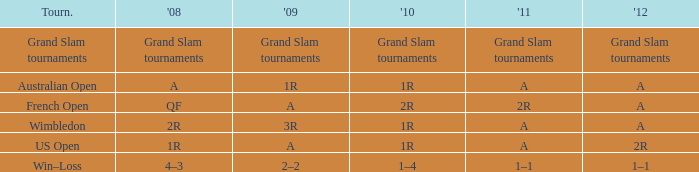Could you parse the entire table as a dict? {'header': ['Tourn.', "'08", "'09", "'10", "'11", "'12"], 'rows': [['Grand Slam tournaments', 'Grand Slam tournaments', 'Grand Slam tournaments', 'Grand Slam tournaments', 'Grand Slam tournaments', 'Grand Slam tournaments'], ['Australian Open', 'A', '1R', '1R', 'A', 'A'], ['French Open', 'QF', 'A', '2R', '2R', 'A'], ['Wimbledon', '2R', '3R', '1R', 'A', 'A'], ['US Open', '1R', 'A', '1R', 'A', '2R'], ['Win–Loss', '4–3', '2–2', '1–4', '1–1', '1–1']]} Name the 2011 for 2012 of a and 2010 of 1r with 2008 of 2r A. 